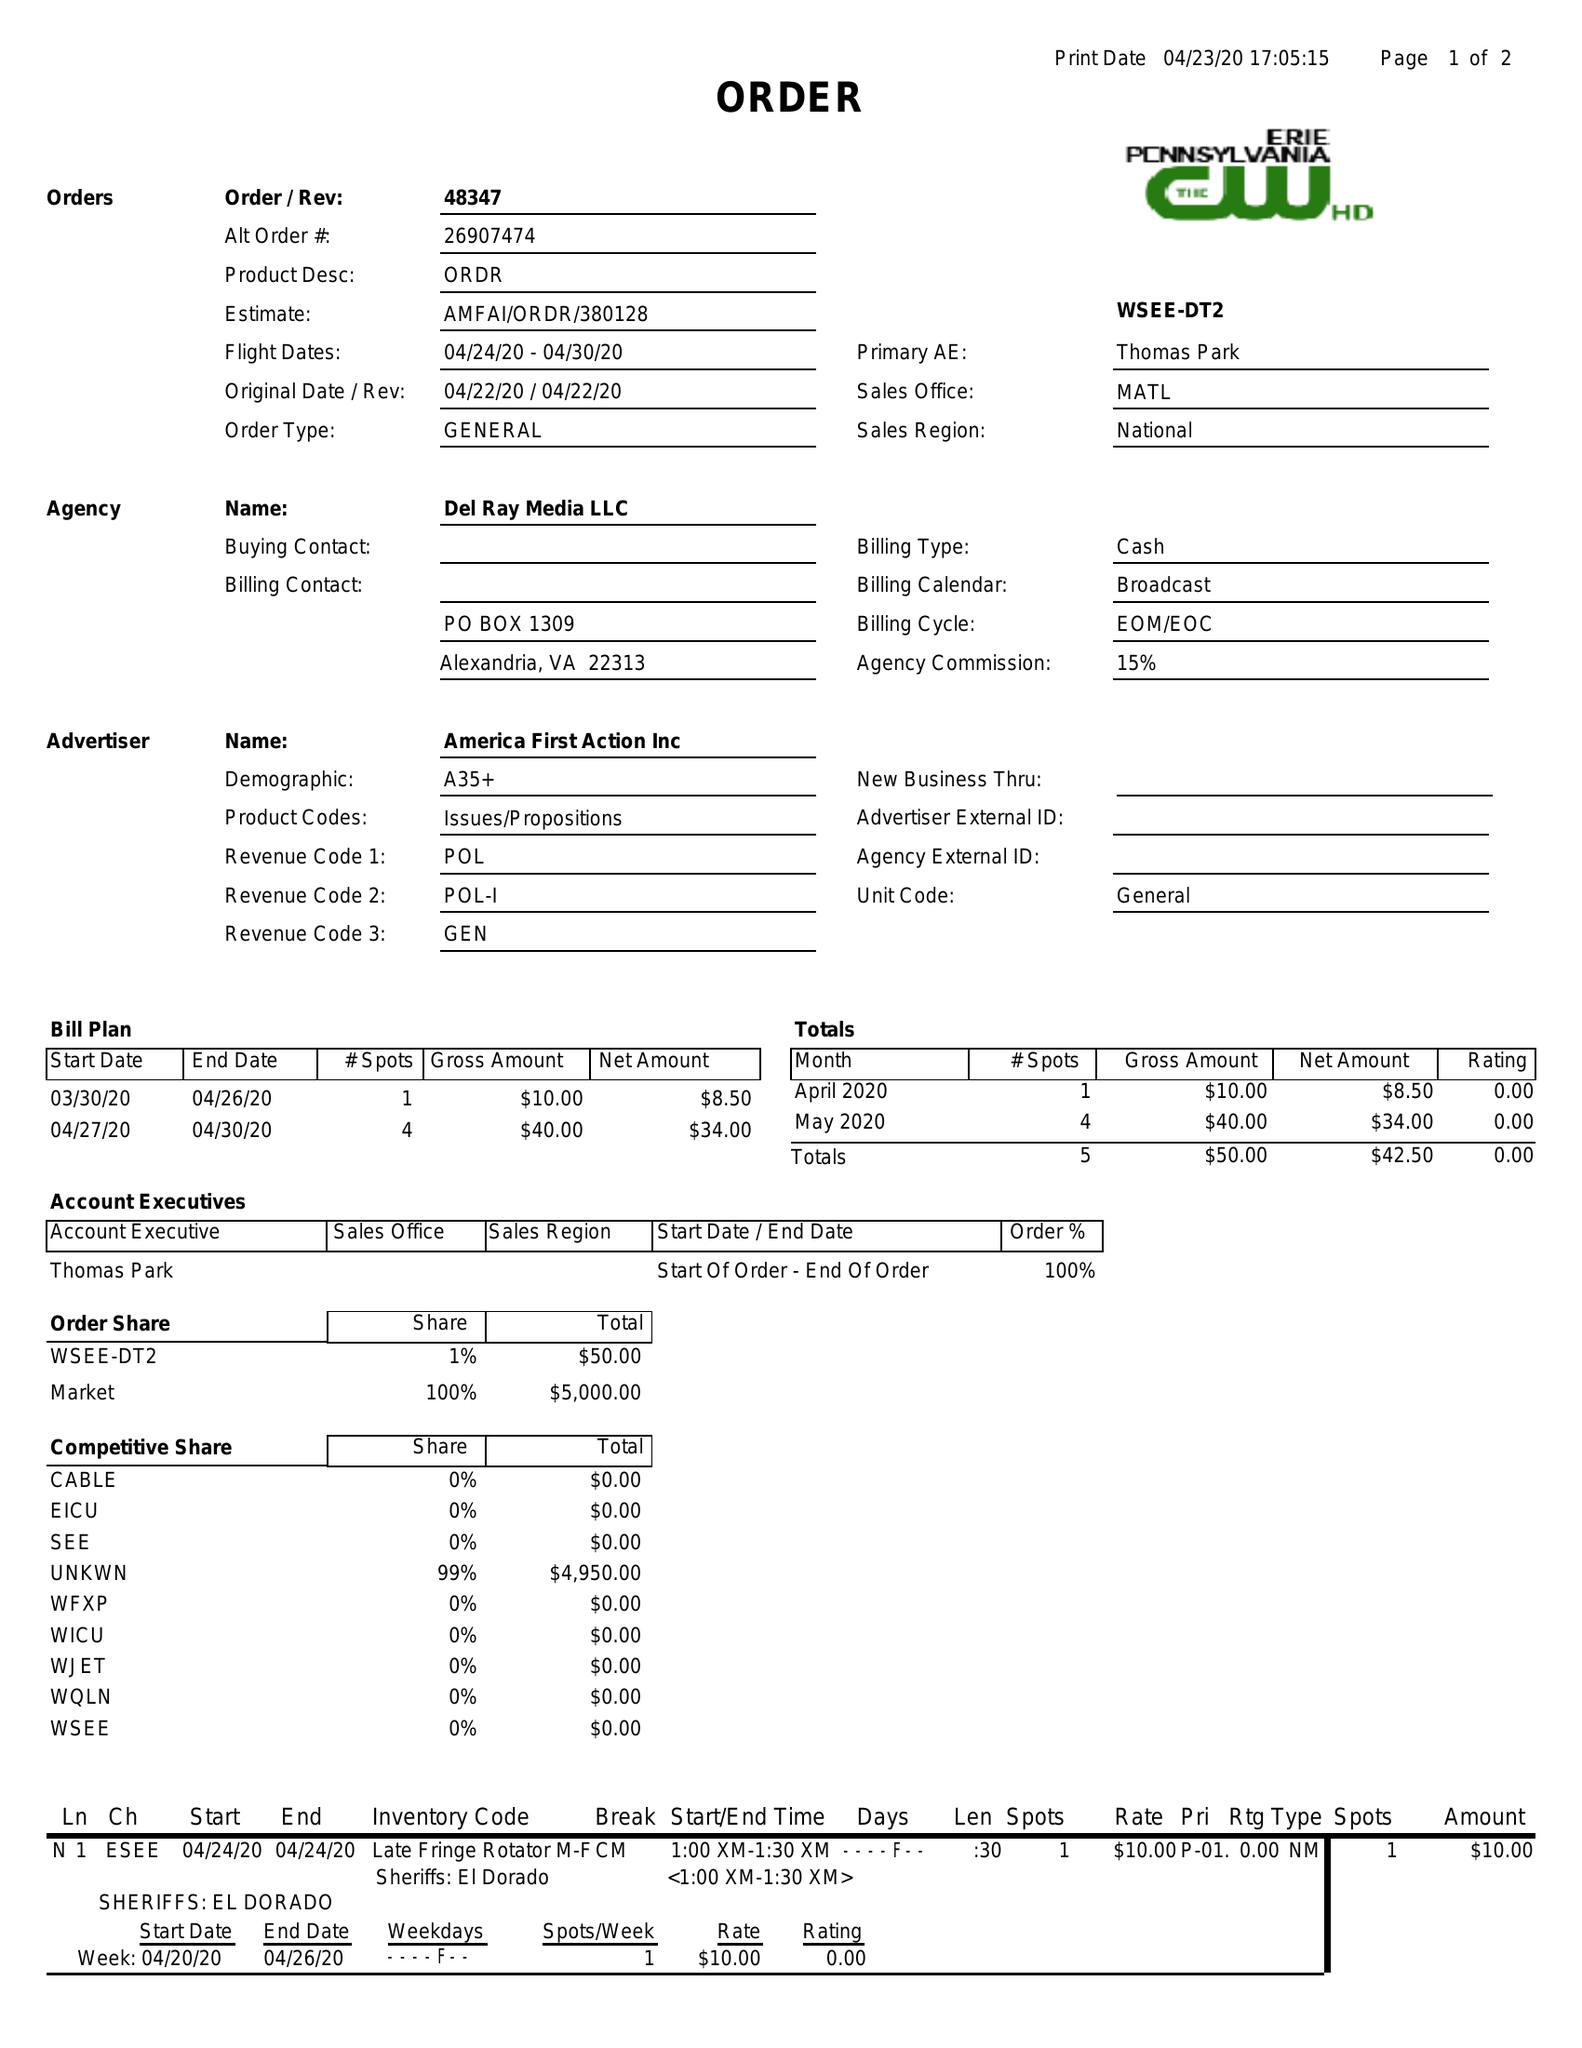What is the value for the flight_to?
Answer the question using a single word or phrase. 04/30/20 